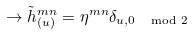<formula> <loc_0><loc_0><loc_500><loc_500>\to { \tilde { h } } _ { ( u ) } ^ { m n } = \eta ^ { m n } \delta _ { u , 0 \, \mod 2 }</formula> 